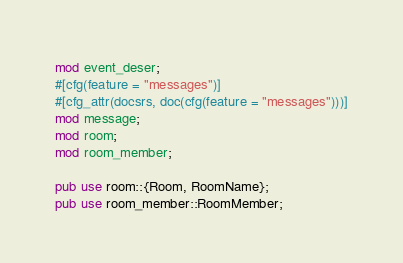Convert code to text. <code><loc_0><loc_0><loc_500><loc_500><_Rust_>mod event_deser;
#[cfg(feature = "messages")]
#[cfg_attr(docsrs, doc(cfg(feature = "messages")))]
mod message;
mod room;
mod room_member;

pub use room::{Room, RoomName};
pub use room_member::RoomMember;
</code> 